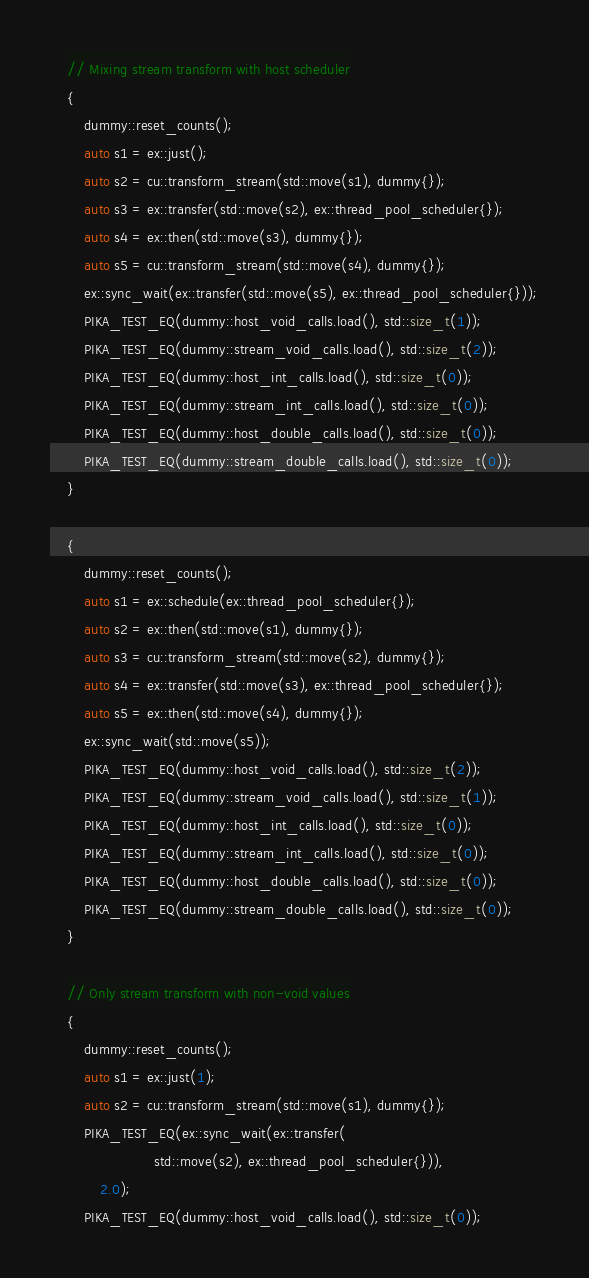<code> <loc_0><loc_0><loc_500><loc_500><_Cuda_>    // Mixing stream transform with host scheduler
    {
        dummy::reset_counts();
        auto s1 = ex::just();
        auto s2 = cu::transform_stream(std::move(s1), dummy{});
        auto s3 = ex::transfer(std::move(s2), ex::thread_pool_scheduler{});
        auto s4 = ex::then(std::move(s3), dummy{});
        auto s5 = cu::transform_stream(std::move(s4), dummy{});
        ex::sync_wait(ex::transfer(std::move(s5), ex::thread_pool_scheduler{}));
        PIKA_TEST_EQ(dummy::host_void_calls.load(), std::size_t(1));
        PIKA_TEST_EQ(dummy::stream_void_calls.load(), std::size_t(2));
        PIKA_TEST_EQ(dummy::host_int_calls.load(), std::size_t(0));
        PIKA_TEST_EQ(dummy::stream_int_calls.load(), std::size_t(0));
        PIKA_TEST_EQ(dummy::host_double_calls.load(), std::size_t(0));
        PIKA_TEST_EQ(dummy::stream_double_calls.load(), std::size_t(0));
    }

    {
        dummy::reset_counts();
        auto s1 = ex::schedule(ex::thread_pool_scheduler{});
        auto s2 = ex::then(std::move(s1), dummy{});
        auto s3 = cu::transform_stream(std::move(s2), dummy{});
        auto s4 = ex::transfer(std::move(s3), ex::thread_pool_scheduler{});
        auto s5 = ex::then(std::move(s4), dummy{});
        ex::sync_wait(std::move(s5));
        PIKA_TEST_EQ(dummy::host_void_calls.load(), std::size_t(2));
        PIKA_TEST_EQ(dummy::stream_void_calls.load(), std::size_t(1));
        PIKA_TEST_EQ(dummy::host_int_calls.load(), std::size_t(0));
        PIKA_TEST_EQ(dummy::stream_int_calls.load(), std::size_t(0));
        PIKA_TEST_EQ(dummy::host_double_calls.load(), std::size_t(0));
        PIKA_TEST_EQ(dummy::stream_double_calls.load(), std::size_t(0));
    }

    // Only stream transform with non-void values
    {
        dummy::reset_counts();
        auto s1 = ex::just(1);
        auto s2 = cu::transform_stream(std::move(s1), dummy{});
        PIKA_TEST_EQ(ex::sync_wait(ex::transfer(
                         std::move(s2), ex::thread_pool_scheduler{})),
            2.0);
        PIKA_TEST_EQ(dummy::host_void_calls.load(), std::size_t(0));</code> 